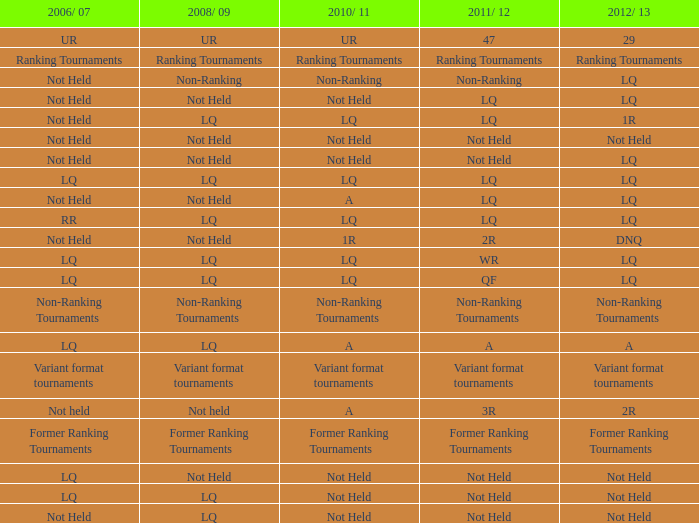What does 2006/07 represent when 2008/09 is labeled as lq and 2010/11 is categorized as not held? LQ, Not Held. 